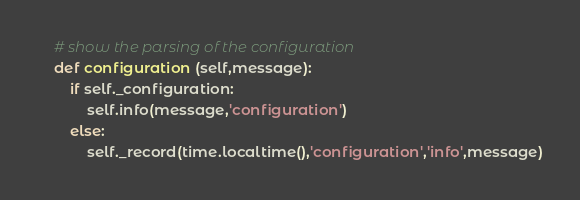Convert code to text. <code><loc_0><loc_0><loc_500><loc_500><_Python_>
	# show the parsing of the configuration
	def configuration (self,message):
		if self._configuration:
			self.info(message,'configuration')
		else:
			self._record(time.localtime(),'configuration','info',message)
</code> 